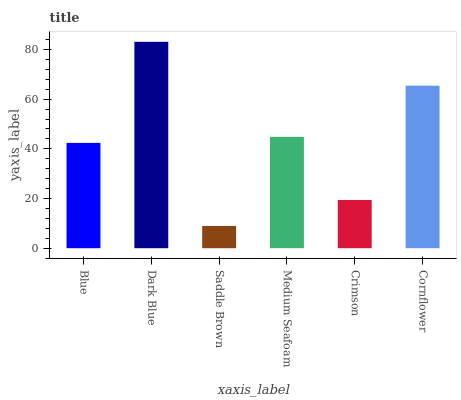Is Saddle Brown the minimum?
Answer yes or no. Yes. Is Dark Blue the maximum?
Answer yes or no. Yes. Is Dark Blue the minimum?
Answer yes or no. No. Is Saddle Brown the maximum?
Answer yes or no. No. Is Dark Blue greater than Saddle Brown?
Answer yes or no. Yes. Is Saddle Brown less than Dark Blue?
Answer yes or no. Yes. Is Saddle Brown greater than Dark Blue?
Answer yes or no. No. Is Dark Blue less than Saddle Brown?
Answer yes or no. No. Is Medium Seafoam the high median?
Answer yes or no. Yes. Is Blue the low median?
Answer yes or no. Yes. Is Cornflower the high median?
Answer yes or no. No. Is Saddle Brown the low median?
Answer yes or no. No. 